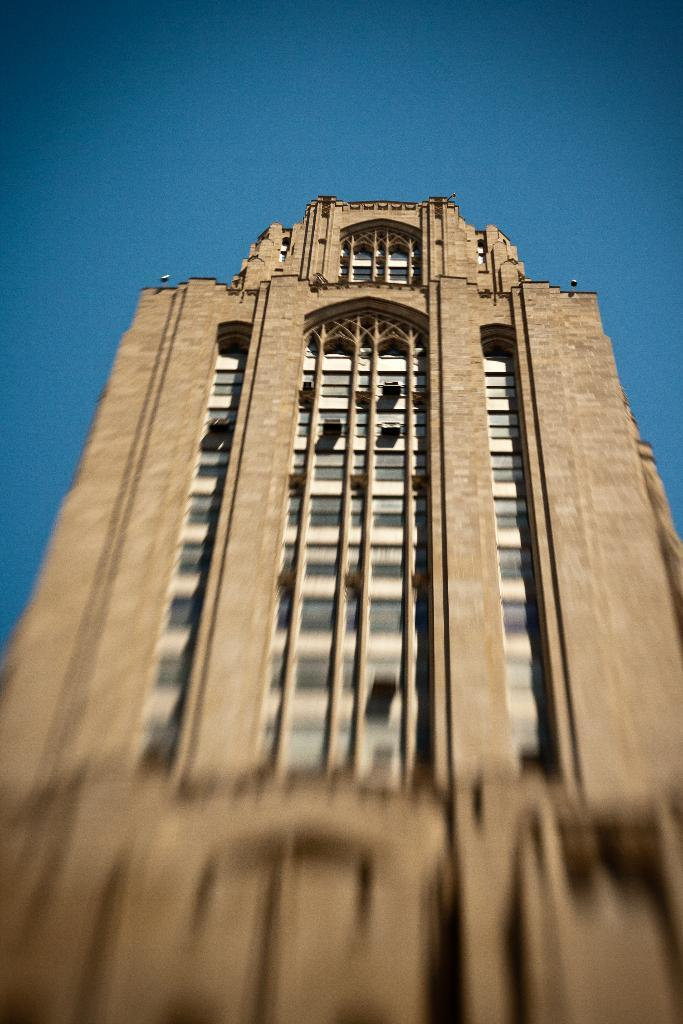What is the main subject in the center of the image? There is a building in the center of the image. What can be seen in the background of the image? The sky is visible in the background of the image. What type of vein is visible in the image? There is no vein present in the image; it features a building and the sky. Can you tell me how many dolls are in the image? There are no dolls present in the image. 